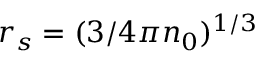<formula> <loc_0><loc_0><loc_500><loc_500>r _ { s } = ( 3 / 4 \pi n _ { 0 } ) ^ { 1 / 3 }</formula> 